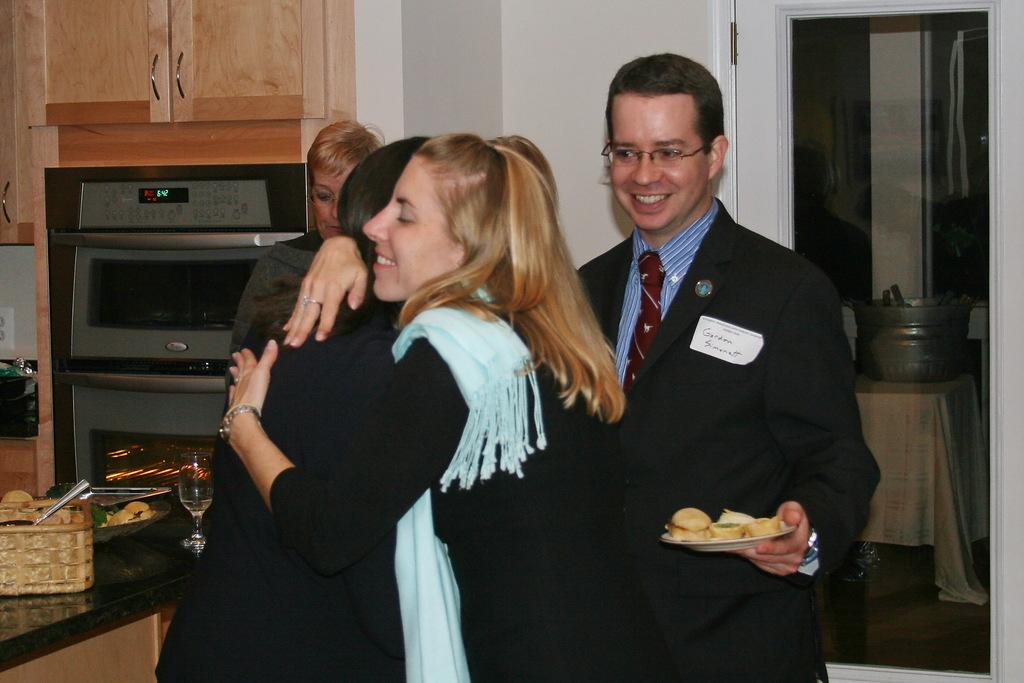<image>
Present a compact description of the photo's key features. Gordon Simonatt watching two girls hug in a kitchen 